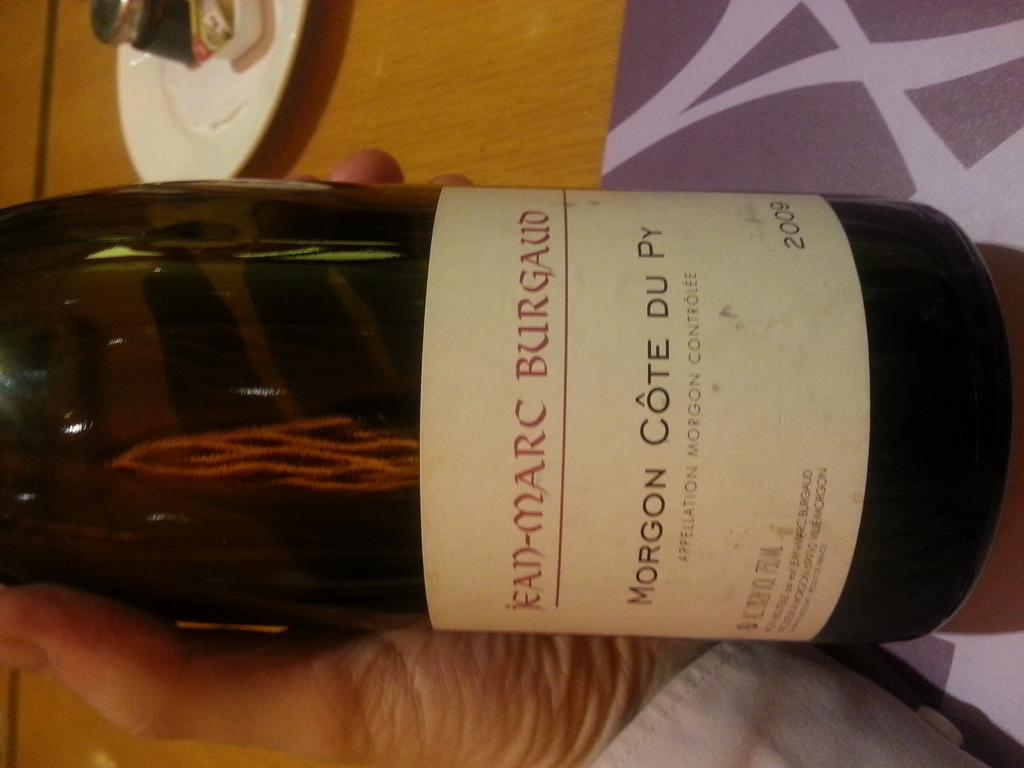<image>
Share a concise interpretation of the image provided. A hand holds a bottle of Jean-Marc Burgaud wine. 